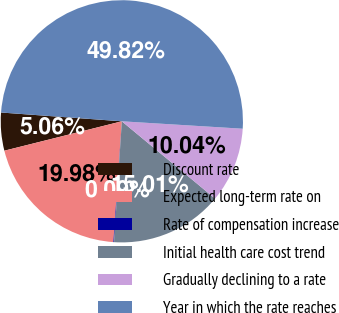<chart> <loc_0><loc_0><loc_500><loc_500><pie_chart><fcel>Discount rate<fcel>Expected long-term rate on<fcel>Rate of compensation increase<fcel>Initial health care cost trend<fcel>Gradually declining to a rate<fcel>Year in which the rate reaches<nl><fcel>5.06%<fcel>19.98%<fcel>0.09%<fcel>15.01%<fcel>10.04%<fcel>49.82%<nl></chart> 